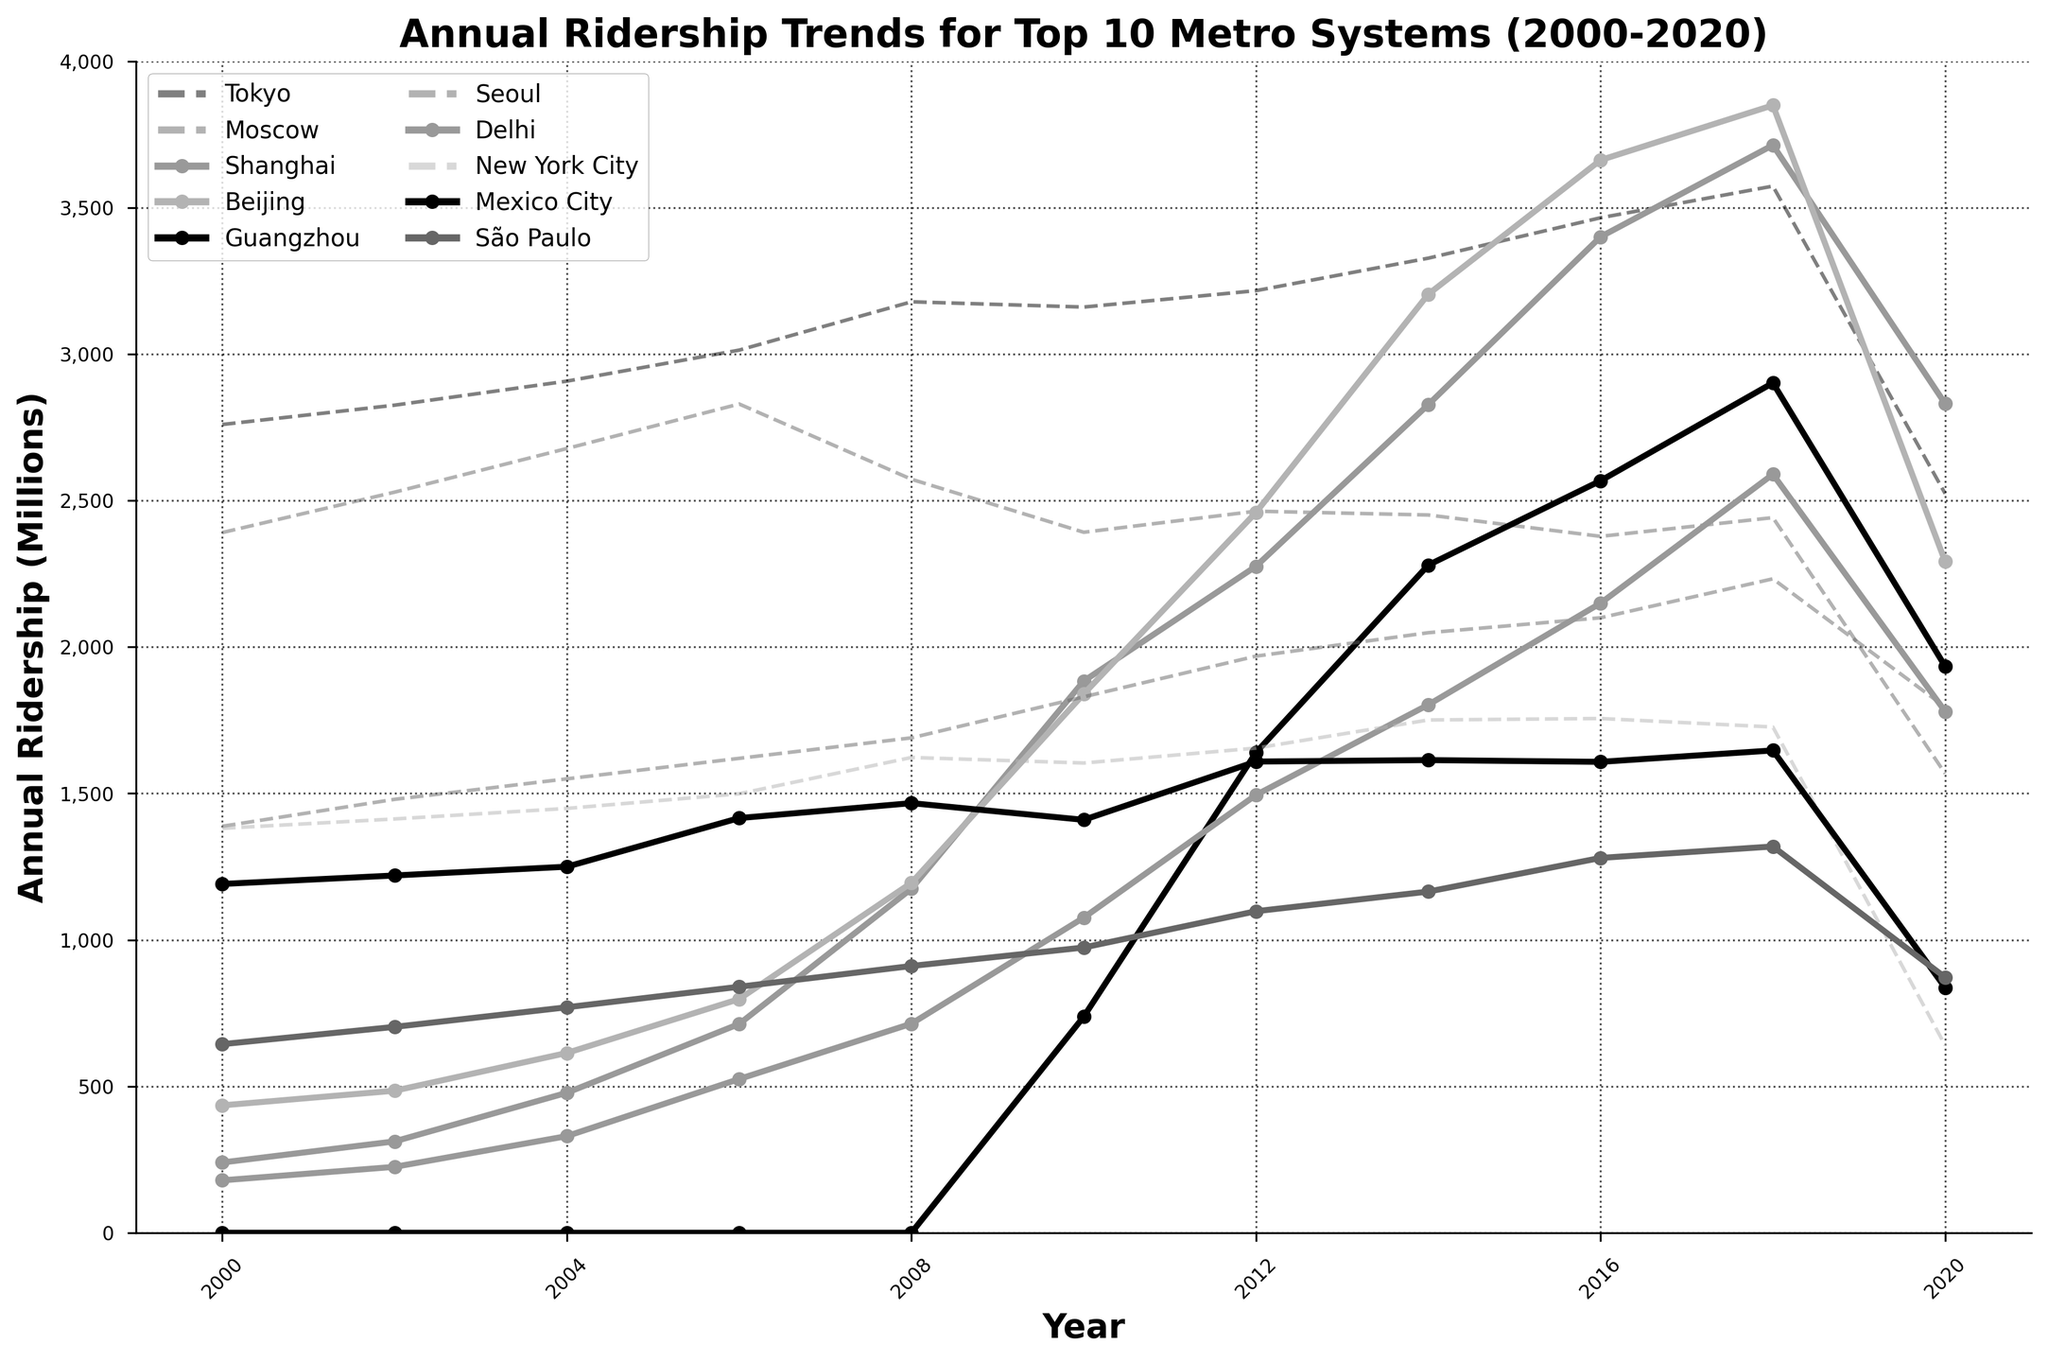What is the overall trend in ridership for the metro system in Delhi from 2000 to 2020? To determine the overall trend, observe the line representing Delhi's ridership, which starts at 179 million in 2000 and rises to 1780 million in 2020. This shows a significant increase in ridership over the two decades.
Answer: Significant increase Which metro system in developing nations had the highest ridership in 2010? Identify the highest data point among Shanghai, Beijing, Guangzhou, Delhi, Mexico City, and São Paulo for the year 2010. Beijing had the highest with 1840 million rides.
Answer: Beijing By how much did São Paulo's ridership increase from 2000 to 2018? São Paulo's ridership in 2000 was 644 million, and in 2018 it was 1319 million. The increase is 1319 - 644 = 675 million.
Answer: 675 million Which two metro systems showed the most significant decrease in ridership between 2018 and 2020? Identify the two lines with the steepest downward slopes between 2018 and 2020. Tokyo and Moscow showed the largest drops, from 3574 million to 2524 million, and from 2442 million to 1568 million, respectively.
Answer: Tokyo and Moscow What are the two highest peaks observed in the annual ridership trends for all metro systems? Identify the two highest points on the graph. Tokyo peaks at 3574 million in 2018, and Shanghai peaks at 3714 million in 2018.
Answer: Tokyo and Shanghai in 2018 Compare the ridership trends for Tokyo and New York City between 2000 and 2020. Tokyo shows a generally increasing trend peaking at 3574 million in 2018, but then drops to 2524 million in 2020. New York City's ridership gradually increases to 1756 million by 2016 and then drops sharply to 640 million in 2020.
Answer: Tokyo increased, then decreased; NYC increased, then sharply decreased Did any developing nation's metro system ever surpass Tokyo's ridership in any year? Tokyo's highest ridership is 3574 million in 2018. The only system from developing nations that surpassed this number is Shanghai with 3714 million in 2018.
Answer: Yes, Shanghai in 2018 How did the ridership in Moscow change from 2000 to 2020? Moscow's ridership decreased from 2391 million in 2000 to 1568 million in 2020.
Answer: Decreased What's the average annual ridership of the Guangzhou metro system from 2010 to 2020? Sum the ridership values of Guangzhou from 2010 (738) to 2020 (1934) and divide by the number of years (11). (738 + 1640 + 2280 + 2568 + 2902 + 1934) / 6 = 2010.33 million.
Answer: 2010.33 million Which metro system had the most consistent ridership trend from 2000 to 2020? Looking for relatively steady lines without significant spikes or plunges, Seoul shows a steadier increase from 1388 million in 2000 to 1795 million in 2020 without significant volatility.
Answer: Seoul 